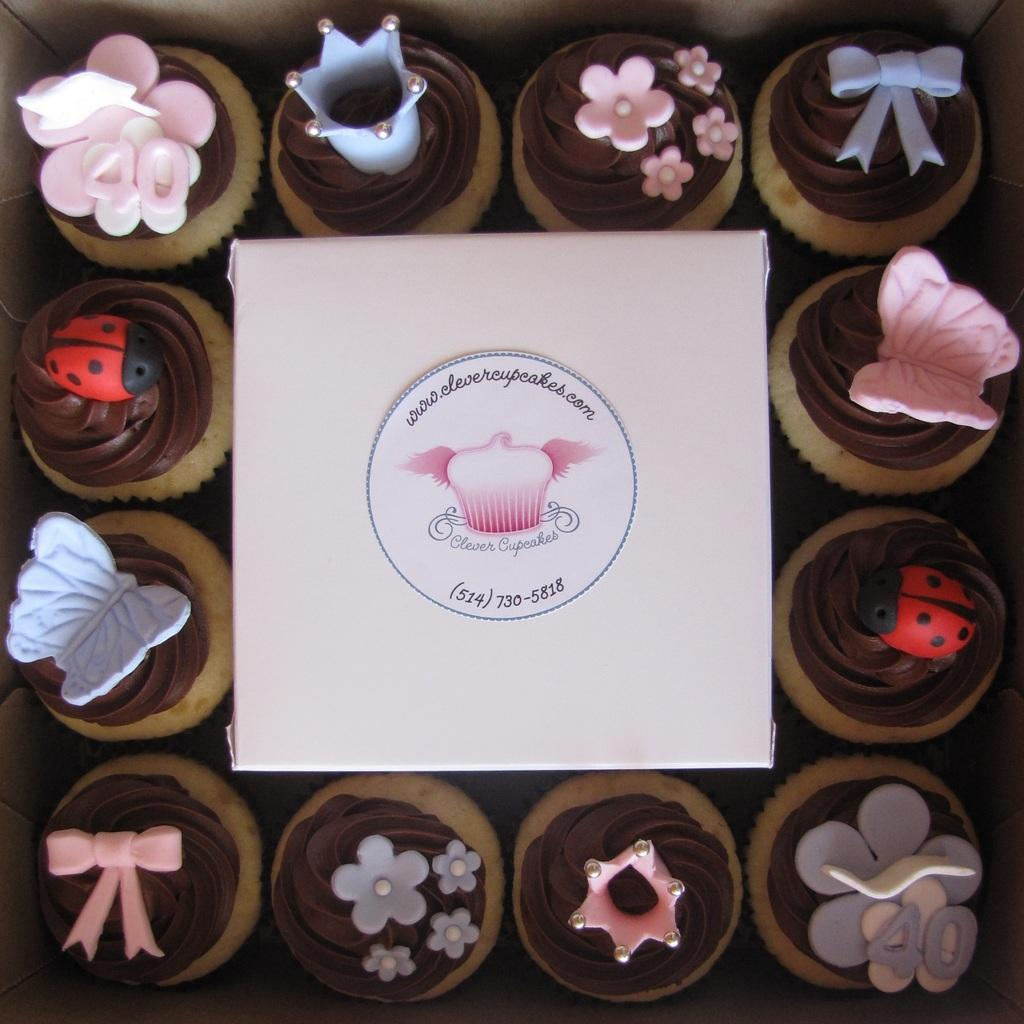What type of food is featured in the image? There are many cupcakes in the image. How are the cupcakes presented? The cupcakes are designed beautifully. What else can be seen in the image besides the cupcakes? There is a poster in the image. What is the name of the poster? The poster is named "CLEVER CUPCAKES." What type of weather can be seen in the image? There is no weather depicted in the image; it focuses on cupcakes and a poster. 